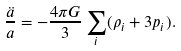<formula> <loc_0><loc_0><loc_500><loc_500>\frac { \ddot { a } } { a } = - \frac { 4 \pi G } { 3 } \sum _ { i } ( \rho _ { i } + 3 p _ { i } ) .</formula> 